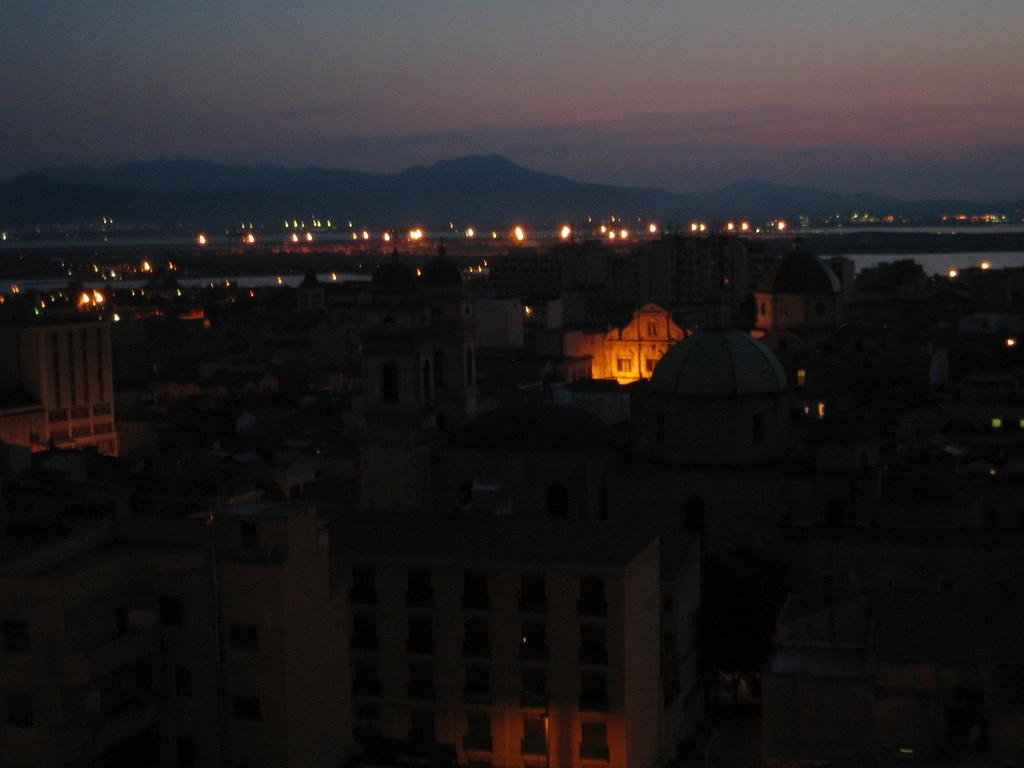What type of structures can be seen in the image? There are many buildings in the image. What can be seen in the background of the image? Lights, water, mountains, and the sky are visible in the background. What is the condition of the sky in the image? The sky is visible at the top of the image, and clouds are present in it. What type of knee can be seen in the image? There is no knee present in the image; it features buildings, lights, water, mountains, and the sky. 